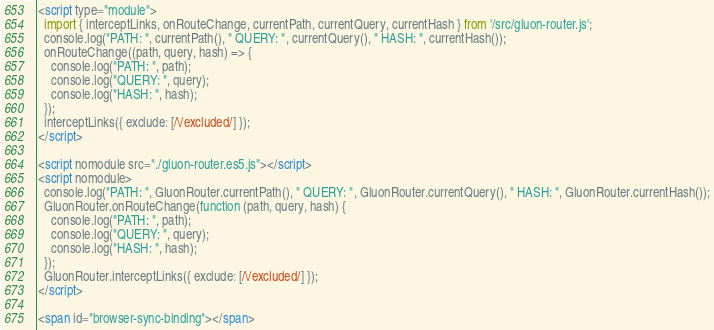Convert code to text. <code><loc_0><loc_0><loc_500><loc_500><_HTML_><script type="module">
  import { interceptLinks, onRouteChange, currentPath, currentQuery, currentHash } from '/src/gluon-router.js';
  console.log("PATH: ", currentPath(), " QUERY: ", currentQuery(), " HASH: ", currentHash());
  onRouteChange((path, query, hash) => {
    console.log("PATH: ", path);
    console.log("QUERY: ", query);
    console.log("HASH: ", hash);
  });
  interceptLinks({ exclude: [/\/excluded/] });
</script>

<script nomodule src="./gluon-router.es5.js"></script>
<script nomodule>
  console.log("PATH: ", GluonRouter.currentPath(), " QUERY: ", GluonRouter.currentQuery(), " HASH: ", GluonRouter.currentHash());
  GluonRouter.onRouteChange(function (path, query, hash) {
    console.log("PATH: ", path);
    console.log("QUERY: ", query);
    console.log("HASH: ", hash);
  });
  GluonRouter.interceptLinks({ exclude: [/\/excluded/] });
</script>

<span id="browser-sync-binding"></span></code> 